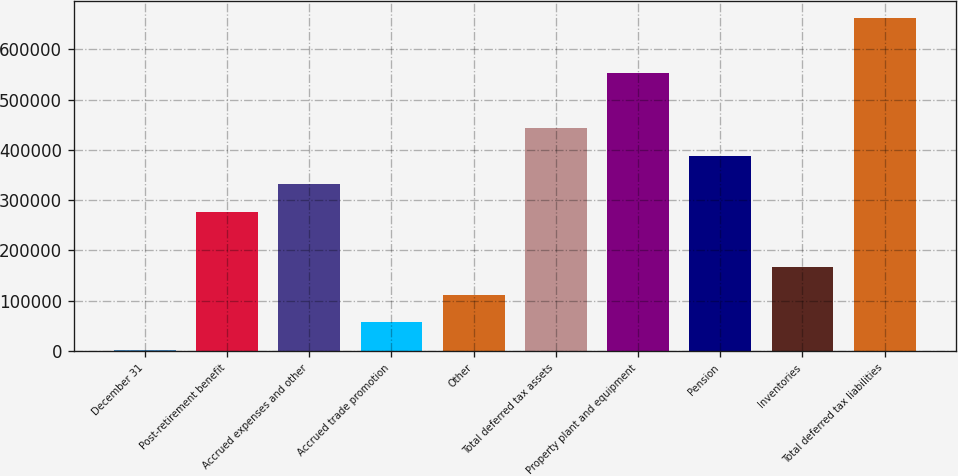Convert chart. <chart><loc_0><loc_0><loc_500><loc_500><bar_chart><fcel>December 31<fcel>Post-retirement benefit<fcel>Accrued expenses and other<fcel>Accrued trade promotion<fcel>Other<fcel>Total deferred tax assets<fcel>Property plant and equipment<fcel>Pension<fcel>Inventories<fcel>Total deferred tax liabilities<nl><fcel>2004<fcel>277384<fcel>332460<fcel>57080<fcel>112156<fcel>442612<fcel>552764<fcel>387536<fcel>167232<fcel>662916<nl></chart> 